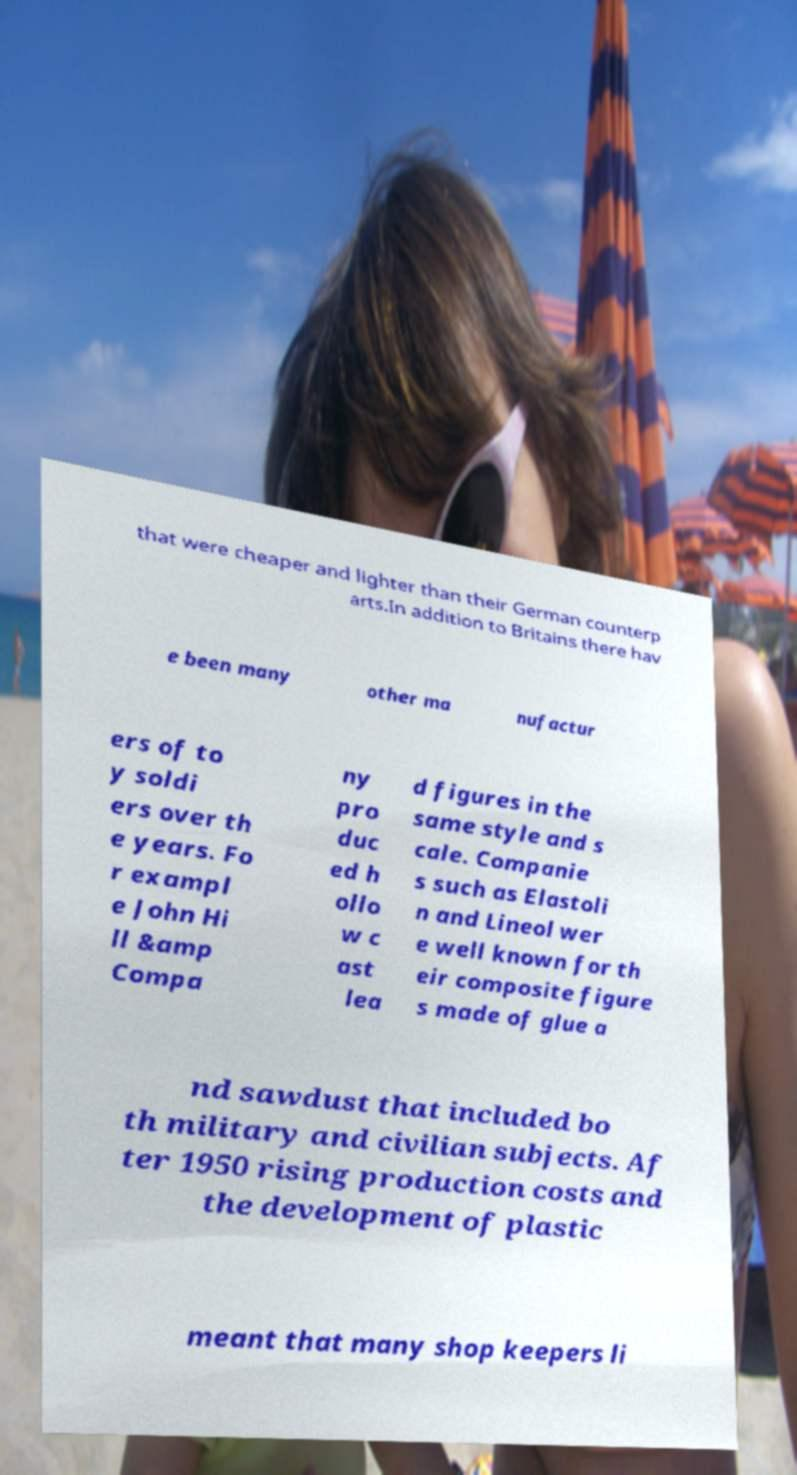Can you accurately transcribe the text from the provided image for me? that were cheaper and lighter than their German counterp arts.In addition to Britains there hav e been many other ma nufactur ers of to y soldi ers over th e years. Fo r exampl e John Hi ll &amp Compa ny pro duc ed h ollo w c ast lea d figures in the same style and s cale. Companie s such as Elastoli n and Lineol wer e well known for th eir composite figure s made of glue a nd sawdust that included bo th military and civilian subjects. Af ter 1950 rising production costs and the development of plastic meant that many shop keepers li 